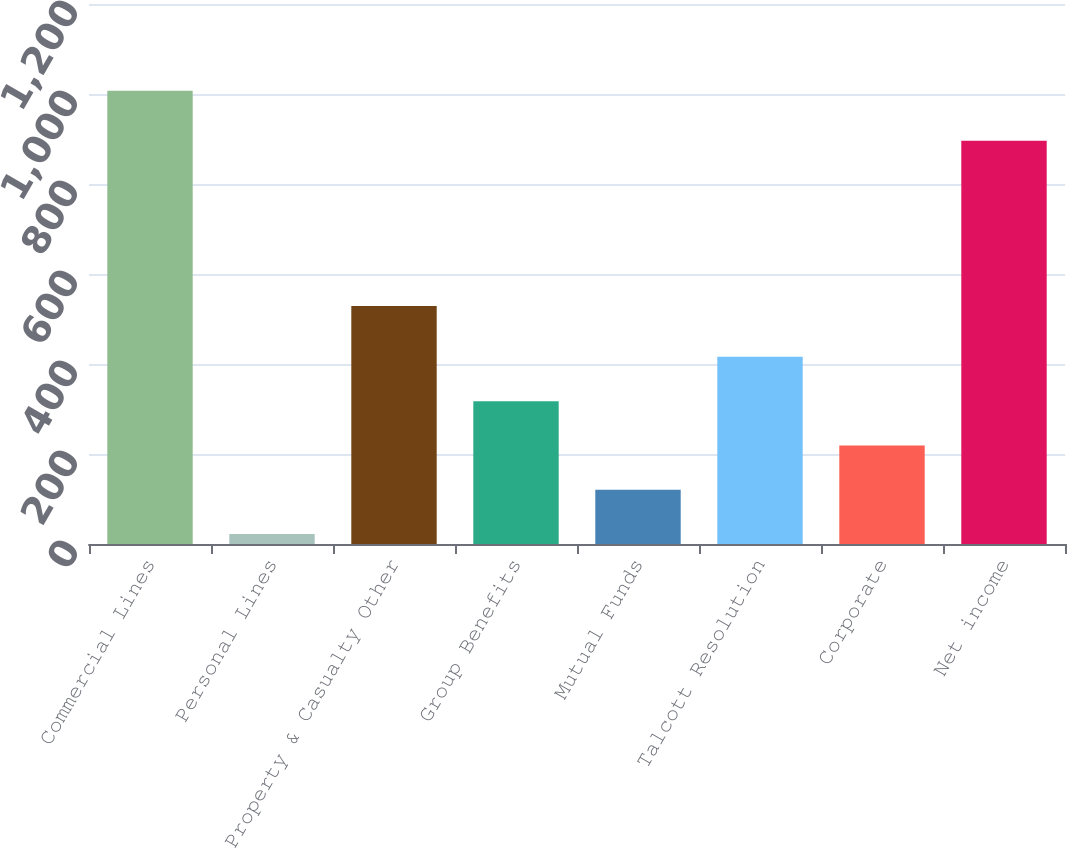Convert chart to OTSL. <chart><loc_0><loc_0><loc_500><loc_500><bar_chart><fcel>Commercial Lines<fcel>Personal Lines<fcel>Property & Casualty Other<fcel>Group Benefits<fcel>Mutual Funds<fcel>Talcott Resolution<fcel>Corporate<fcel>Net income<nl><fcel>1007<fcel>22<fcel>529<fcel>317.5<fcel>120.5<fcel>416<fcel>219<fcel>896<nl></chart> 